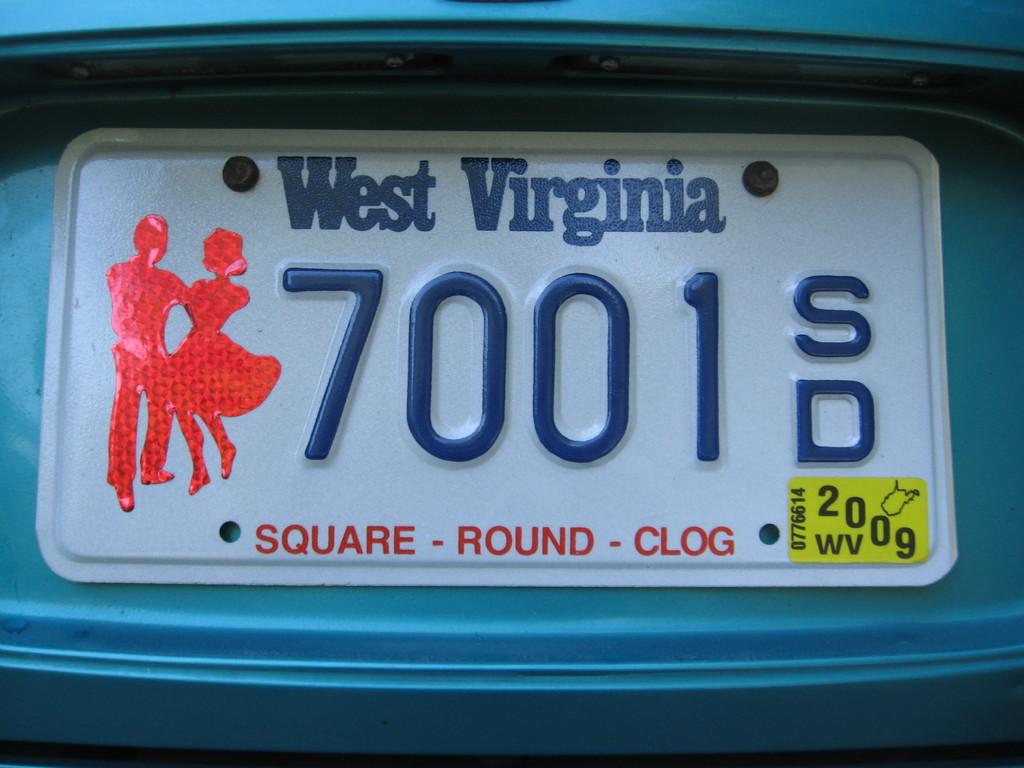What state is the license plate?
Your response must be concise. West virginia. What three words are written in red?
Provide a succinct answer. Square round clog. 